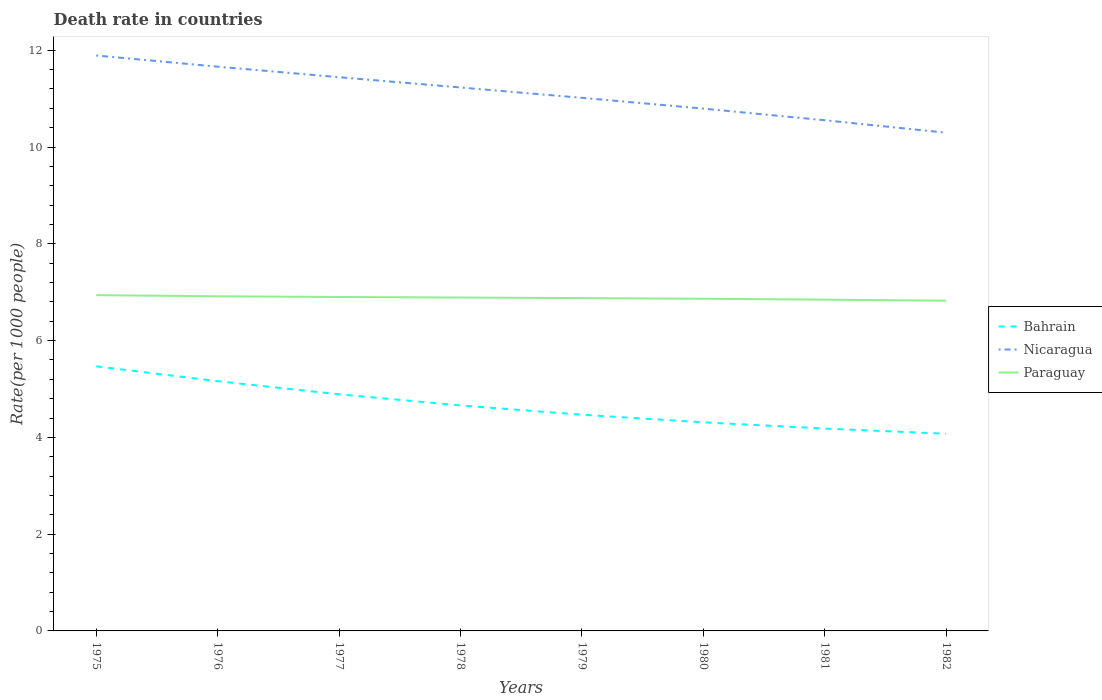Across all years, what is the maximum death rate in Bahrain?
Keep it short and to the point. 4.08. In which year was the death rate in Nicaragua maximum?
Your answer should be compact. 1982. What is the total death rate in Bahrain in the graph?
Your response must be concise. 0.58. What is the difference between the highest and the second highest death rate in Nicaragua?
Provide a short and direct response. 1.6. How many lines are there?
Your response must be concise. 3. What is the difference between two consecutive major ticks on the Y-axis?
Give a very brief answer. 2. Does the graph contain any zero values?
Your answer should be very brief. No. Does the graph contain grids?
Provide a short and direct response. No. How many legend labels are there?
Keep it short and to the point. 3. How are the legend labels stacked?
Offer a terse response. Vertical. What is the title of the graph?
Your answer should be compact. Death rate in countries. Does "Aruba" appear as one of the legend labels in the graph?
Give a very brief answer. No. What is the label or title of the Y-axis?
Provide a succinct answer. Rate(per 1000 people). What is the Rate(per 1000 people) of Bahrain in 1975?
Ensure brevity in your answer.  5.47. What is the Rate(per 1000 people) in Nicaragua in 1975?
Your response must be concise. 11.89. What is the Rate(per 1000 people) in Paraguay in 1975?
Your response must be concise. 6.94. What is the Rate(per 1000 people) of Bahrain in 1976?
Provide a succinct answer. 5.16. What is the Rate(per 1000 people) in Nicaragua in 1976?
Provide a short and direct response. 11.66. What is the Rate(per 1000 people) in Paraguay in 1976?
Keep it short and to the point. 6.92. What is the Rate(per 1000 people) in Bahrain in 1977?
Your answer should be compact. 4.89. What is the Rate(per 1000 people) of Nicaragua in 1977?
Your answer should be very brief. 11.44. What is the Rate(per 1000 people) of Paraguay in 1977?
Offer a terse response. 6.9. What is the Rate(per 1000 people) of Bahrain in 1978?
Offer a terse response. 4.66. What is the Rate(per 1000 people) in Nicaragua in 1978?
Provide a succinct answer. 11.23. What is the Rate(per 1000 people) of Paraguay in 1978?
Make the answer very short. 6.89. What is the Rate(per 1000 people) in Bahrain in 1979?
Provide a short and direct response. 4.47. What is the Rate(per 1000 people) in Nicaragua in 1979?
Give a very brief answer. 11.02. What is the Rate(per 1000 people) in Paraguay in 1979?
Your response must be concise. 6.88. What is the Rate(per 1000 people) in Bahrain in 1980?
Keep it short and to the point. 4.31. What is the Rate(per 1000 people) in Nicaragua in 1980?
Provide a short and direct response. 10.79. What is the Rate(per 1000 people) of Paraguay in 1980?
Provide a short and direct response. 6.86. What is the Rate(per 1000 people) of Bahrain in 1981?
Provide a short and direct response. 4.18. What is the Rate(per 1000 people) of Nicaragua in 1981?
Your response must be concise. 10.55. What is the Rate(per 1000 people) of Paraguay in 1981?
Your answer should be compact. 6.85. What is the Rate(per 1000 people) of Bahrain in 1982?
Offer a terse response. 4.08. What is the Rate(per 1000 people) of Nicaragua in 1982?
Offer a terse response. 10.3. What is the Rate(per 1000 people) of Paraguay in 1982?
Give a very brief answer. 6.82. Across all years, what is the maximum Rate(per 1000 people) of Bahrain?
Provide a short and direct response. 5.47. Across all years, what is the maximum Rate(per 1000 people) in Nicaragua?
Your response must be concise. 11.89. Across all years, what is the maximum Rate(per 1000 people) in Paraguay?
Offer a terse response. 6.94. Across all years, what is the minimum Rate(per 1000 people) in Bahrain?
Offer a very short reply. 4.08. Across all years, what is the minimum Rate(per 1000 people) in Nicaragua?
Ensure brevity in your answer.  10.3. Across all years, what is the minimum Rate(per 1000 people) in Paraguay?
Ensure brevity in your answer.  6.82. What is the total Rate(per 1000 people) of Bahrain in the graph?
Give a very brief answer. 37.22. What is the total Rate(per 1000 people) of Nicaragua in the graph?
Make the answer very short. 88.89. What is the total Rate(per 1000 people) of Paraguay in the graph?
Offer a terse response. 55.06. What is the difference between the Rate(per 1000 people) of Bahrain in 1975 and that in 1976?
Your answer should be compact. 0.31. What is the difference between the Rate(per 1000 people) of Nicaragua in 1975 and that in 1976?
Your answer should be compact. 0.23. What is the difference between the Rate(per 1000 people) of Paraguay in 1975 and that in 1976?
Keep it short and to the point. 0.02. What is the difference between the Rate(per 1000 people) of Bahrain in 1975 and that in 1977?
Your answer should be very brief. 0.58. What is the difference between the Rate(per 1000 people) in Nicaragua in 1975 and that in 1977?
Provide a succinct answer. 0.45. What is the difference between the Rate(per 1000 people) of Paraguay in 1975 and that in 1977?
Give a very brief answer. 0.04. What is the difference between the Rate(per 1000 people) of Bahrain in 1975 and that in 1978?
Keep it short and to the point. 0.81. What is the difference between the Rate(per 1000 people) of Nicaragua in 1975 and that in 1978?
Your response must be concise. 0.66. What is the difference between the Rate(per 1000 people) in Paraguay in 1975 and that in 1978?
Make the answer very short. 0.05. What is the difference between the Rate(per 1000 people) of Bahrain in 1975 and that in 1979?
Your answer should be compact. 1. What is the difference between the Rate(per 1000 people) of Paraguay in 1975 and that in 1979?
Your response must be concise. 0.06. What is the difference between the Rate(per 1000 people) of Bahrain in 1975 and that in 1980?
Your response must be concise. 1.16. What is the difference between the Rate(per 1000 people) in Nicaragua in 1975 and that in 1980?
Keep it short and to the point. 1.1. What is the difference between the Rate(per 1000 people) in Paraguay in 1975 and that in 1980?
Offer a very short reply. 0.07. What is the difference between the Rate(per 1000 people) in Bahrain in 1975 and that in 1981?
Give a very brief answer. 1.29. What is the difference between the Rate(per 1000 people) of Nicaragua in 1975 and that in 1981?
Provide a succinct answer. 1.34. What is the difference between the Rate(per 1000 people) of Paraguay in 1975 and that in 1981?
Your answer should be compact. 0.09. What is the difference between the Rate(per 1000 people) in Bahrain in 1975 and that in 1982?
Your answer should be very brief. 1.39. What is the difference between the Rate(per 1000 people) in Nicaragua in 1975 and that in 1982?
Ensure brevity in your answer.  1.6. What is the difference between the Rate(per 1000 people) of Paraguay in 1975 and that in 1982?
Offer a terse response. 0.12. What is the difference between the Rate(per 1000 people) of Bahrain in 1976 and that in 1977?
Ensure brevity in your answer.  0.27. What is the difference between the Rate(per 1000 people) in Nicaragua in 1976 and that in 1977?
Make the answer very short. 0.22. What is the difference between the Rate(per 1000 people) in Paraguay in 1976 and that in 1977?
Offer a terse response. 0.01. What is the difference between the Rate(per 1000 people) in Bahrain in 1976 and that in 1978?
Ensure brevity in your answer.  0.5. What is the difference between the Rate(per 1000 people) of Nicaragua in 1976 and that in 1978?
Provide a succinct answer. 0.43. What is the difference between the Rate(per 1000 people) of Paraguay in 1976 and that in 1978?
Give a very brief answer. 0.03. What is the difference between the Rate(per 1000 people) of Bahrain in 1976 and that in 1979?
Provide a short and direct response. 0.69. What is the difference between the Rate(per 1000 people) of Nicaragua in 1976 and that in 1979?
Ensure brevity in your answer.  0.64. What is the difference between the Rate(per 1000 people) of Paraguay in 1976 and that in 1979?
Keep it short and to the point. 0.04. What is the difference between the Rate(per 1000 people) in Nicaragua in 1976 and that in 1980?
Your answer should be compact. 0.87. What is the difference between the Rate(per 1000 people) in Paraguay in 1976 and that in 1980?
Keep it short and to the point. 0.05. What is the difference between the Rate(per 1000 people) in Nicaragua in 1976 and that in 1981?
Ensure brevity in your answer.  1.11. What is the difference between the Rate(per 1000 people) in Paraguay in 1976 and that in 1981?
Offer a very short reply. 0.07. What is the difference between the Rate(per 1000 people) of Bahrain in 1976 and that in 1982?
Offer a very short reply. 1.09. What is the difference between the Rate(per 1000 people) in Nicaragua in 1976 and that in 1982?
Make the answer very short. 1.36. What is the difference between the Rate(per 1000 people) in Paraguay in 1976 and that in 1982?
Keep it short and to the point. 0.09. What is the difference between the Rate(per 1000 people) of Bahrain in 1977 and that in 1978?
Make the answer very short. 0.23. What is the difference between the Rate(per 1000 people) in Nicaragua in 1977 and that in 1978?
Offer a very short reply. 0.21. What is the difference between the Rate(per 1000 people) of Paraguay in 1977 and that in 1978?
Offer a terse response. 0.01. What is the difference between the Rate(per 1000 people) of Bahrain in 1977 and that in 1979?
Your response must be concise. 0.42. What is the difference between the Rate(per 1000 people) in Nicaragua in 1977 and that in 1979?
Keep it short and to the point. 0.43. What is the difference between the Rate(per 1000 people) of Paraguay in 1977 and that in 1979?
Give a very brief answer. 0.02. What is the difference between the Rate(per 1000 people) in Bahrain in 1977 and that in 1980?
Make the answer very short. 0.58. What is the difference between the Rate(per 1000 people) of Nicaragua in 1977 and that in 1980?
Make the answer very short. 0.65. What is the difference between the Rate(per 1000 people) in Paraguay in 1977 and that in 1980?
Provide a short and direct response. 0.04. What is the difference between the Rate(per 1000 people) in Bahrain in 1977 and that in 1981?
Offer a very short reply. 0.71. What is the difference between the Rate(per 1000 people) of Nicaragua in 1977 and that in 1981?
Offer a terse response. 0.89. What is the difference between the Rate(per 1000 people) of Paraguay in 1977 and that in 1981?
Offer a very short reply. 0.06. What is the difference between the Rate(per 1000 people) of Bahrain in 1977 and that in 1982?
Your answer should be compact. 0.81. What is the difference between the Rate(per 1000 people) of Nicaragua in 1977 and that in 1982?
Your answer should be compact. 1.15. What is the difference between the Rate(per 1000 people) of Paraguay in 1977 and that in 1982?
Your response must be concise. 0.08. What is the difference between the Rate(per 1000 people) in Bahrain in 1978 and that in 1979?
Offer a very short reply. 0.19. What is the difference between the Rate(per 1000 people) in Nicaragua in 1978 and that in 1979?
Provide a short and direct response. 0.21. What is the difference between the Rate(per 1000 people) in Paraguay in 1978 and that in 1979?
Your response must be concise. 0.01. What is the difference between the Rate(per 1000 people) of Bahrain in 1978 and that in 1980?
Your answer should be compact. 0.35. What is the difference between the Rate(per 1000 people) of Nicaragua in 1978 and that in 1980?
Give a very brief answer. 0.44. What is the difference between the Rate(per 1000 people) of Paraguay in 1978 and that in 1980?
Your answer should be compact. 0.03. What is the difference between the Rate(per 1000 people) of Bahrain in 1978 and that in 1981?
Offer a very short reply. 0.48. What is the difference between the Rate(per 1000 people) in Nicaragua in 1978 and that in 1981?
Your answer should be very brief. 0.68. What is the difference between the Rate(per 1000 people) in Paraguay in 1978 and that in 1981?
Your response must be concise. 0.04. What is the difference between the Rate(per 1000 people) of Bahrain in 1978 and that in 1982?
Offer a terse response. 0.58. What is the difference between the Rate(per 1000 people) in Nicaragua in 1978 and that in 1982?
Make the answer very short. 0.94. What is the difference between the Rate(per 1000 people) in Paraguay in 1978 and that in 1982?
Your answer should be compact. 0.07. What is the difference between the Rate(per 1000 people) in Bahrain in 1979 and that in 1980?
Ensure brevity in your answer.  0.16. What is the difference between the Rate(per 1000 people) of Nicaragua in 1979 and that in 1980?
Your answer should be very brief. 0.22. What is the difference between the Rate(per 1000 people) of Paraguay in 1979 and that in 1980?
Your answer should be very brief. 0.01. What is the difference between the Rate(per 1000 people) of Bahrain in 1979 and that in 1981?
Make the answer very short. 0.29. What is the difference between the Rate(per 1000 people) of Nicaragua in 1979 and that in 1981?
Your response must be concise. 0.46. What is the difference between the Rate(per 1000 people) in Paraguay in 1979 and that in 1981?
Ensure brevity in your answer.  0.03. What is the difference between the Rate(per 1000 people) of Bahrain in 1979 and that in 1982?
Your answer should be very brief. 0.39. What is the difference between the Rate(per 1000 people) in Nicaragua in 1979 and that in 1982?
Your answer should be compact. 0.72. What is the difference between the Rate(per 1000 people) in Paraguay in 1979 and that in 1982?
Ensure brevity in your answer.  0.05. What is the difference between the Rate(per 1000 people) of Bahrain in 1980 and that in 1981?
Offer a terse response. 0.13. What is the difference between the Rate(per 1000 people) in Nicaragua in 1980 and that in 1981?
Offer a terse response. 0.24. What is the difference between the Rate(per 1000 people) of Paraguay in 1980 and that in 1981?
Provide a short and direct response. 0.02. What is the difference between the Rate(per 1000 people) of Bahrain in 1980 and that in 1982?
Keep it short and to the point. 0.24. What is the difference between the Rate(per 1000 people) in Nicaragua in 1980 and that in 1982?
Make the answer very short. 0.5. What is the difference between the Rate(per 1000 people) in Paraguay in 1980 and that in 1982?
Your answer should be very brief. 0.04. What is the difference between the Rate(per 1000 people) in Bahrain in 1981 and that in 1982?
Your response must be concise. 0.11. What is the difference between the Rate(per 1000 people) in Nicaragua in 1981 and that in 1982?
Offer a very short reply. 0.26. What is the difference between the Rate(per 1000 people) in Paraguay in 1981 and that in 1982?
Your answer should be very brief. 0.02. What is the difference between the Rate(per 1000 people) in Bahrain in 1975 and the Rate(per 1000 people) in Nicaragua in 1976?
Your answer should be very brief. -6.19. What is the difference between the Rate(per 1000 people) in Bahrain in 1975 and the Rate(per 1000 people) in Paraguay in 1976?
Offer a terse response. -1.45. What is the difference between the Rate(per 1000 people) in Nicaragua in 1975 and the Rate(per 1000 people) in Paraguay in 1976?
Ensure brevity in your answer.  4.98. What is the difference between the Rate(per 1000 people) in Bahrain in 1975 and the Rate(per 1000 people) in Nicaragua in 1977?
Offer a very short reply. -5.97. What is the difference between the Rate(per 1000 people) in Bahrain in 1975 and the Rate(per 1000 people) in Paraguay in 1977?
Your answer should be compact. -1.43. What is the difference between the Rate(per 1000 people) of Nicaragua in 1975 and the Rate(per 1000 people) of Paraguay in 1977?
Your response must be concise. 4.99. What is the difference between the Rate(per 1000 people) in Bahrain in 1975 and the Rate(per 1000 people) in Nicaragua in 1978?
Keep it short and to the point. -5.76. What is the difference between the Rate(per 1000 people) of Bahrain in 1975 and the Rate(per 1000 people) of Paraguay in 1978?
Give a very brief answer. -1.42. What is the difference between the Rate(per 1000 people) of Nicaragua in 1975 and the Rate(per 1000 people) of Paraguay in 1978?
Offer a very short reply. 5. What is the difference between the Rate(per 1000 people) in Bahrain in 1975 and the Rate(per 1000 people) in Nicaragua in 1979?
Keep it short and to the point. -5.55. What is the difference between the Rate(per 1000 people) of Bahrain in 1975 and the Rate(per 1000 people) of Paraguay in 1979?
Your answer should be compact. -1.41. What is the difference between the Rate(per 1000 people) of Nicaragua in 1975 and the Rate(per 1000 people) of Paraguay in 1979?
Provide a short and direct response. 5.01. What is the difference between the Rate(per 1000 people) of Bahrain in 1975 and the Rate(per 1000 people) of Nicaragua in 1980?
Make the answer very short. -5.33. What is the difference between the Rate(per 1000 people) in Bahrain in 1975 and the Rate(per 1000 people) in Paraguay in 1980?
Offer a very short reply. -1.4. What is the difference between the Rate(per 1000 people) of Nicaragua in 1975 and the Rate(per 1000 people) of Paraguay in 1980?
Keep it short and to the point. 5.03. What is the difference between the Rate(per 1000 people) in Bahrain in 1975 and the Rate(per 1000 people) in Nicaragua in 1981?
Ensure brevity in your answer.  -5.09. What is the difference between the Rate(per 1000 people) in Bahrain in 1975 and the Rate(per 1000 people) in Paraguay in 1981?
Ensure brevity in your answer.  -1.38. What is the difference between the Rate(per 1000 people) in Nicaragua in 1975 and the Rate(per 1000 people) in Paraguay in 1981?
Your answer should be compact. 5.05. What is the difference between the Rate(per 1000 people) in Bahrain in 1975 and the Rate(per 1000 people) in Nicaragua in 1982?
Make the answer very short. -4.83. What is the difference between the Rate(per 1000 people) in Bahrain in 1975 and the Rate(per 1000 people) in Paraguay in 1982?
Your answer should be compact. -1.36. What is the difference between the Rate(per 1000 people) in Nicaragua in 1975 and the Rate(per 1000 people) in Paraguay in 1982?
Provide a short and direct response. 5.07. What is the difference between the Rate(per 1000 people) of Bahrain in 1976 and the Rate(per 1000 people) of Nicaragua in 1977?
Keep it short and to the point. -6.28. What is the difference between the Rate(per 1000 people) in Bahrain in 1976 and the Rate(per 1000 people) in Paraguay in 1977?
Keep it short and to the point. -1.74. What is the difference between the Rate(per 1000 people) of Nicaragua in 1976 and the Rate(per 1000 people) of Paraguay in 1977?
Offer a terse response. 4.76. What is the difference between the Rate(per 1000 people) of Bahrain in 1976 and the Rate(per 1000 people) of Nicaragua in 1978?
Offer a very short reply. -6.07. What is the difference between the Rate(per 1000 people) of Bahrain in 1976 and the Rate(per 1000 people) of Paraguay in 1978?
Offer a terse response. -1.73. What is the difference between the Rate(per 1000 people) in Nicaragua in 1976 and the Rate(per 1000 people) in Paraguay in 1978?
Your answer should be compact. 4.77. What is the difference between the Rate(per 1000 people) of Bahrain in 1976 and the Rate(per 1000 people) of Nicaragua in 1979?
Offer a terse response. -5.86. What is the difference between the Rate(per 1000 people) of Bahrain in 1976 and the Rate(per 1000 people) of Paraguay in 1979?
Provide a succinct answer. -1.72. What is the difference between the Rate(per 1000 people) in Nicaragua in 1976 and the Rate(per 1000 people) in Paraguay in 1979?
Offer a very short reply. 4.78. What is the difference between the Rate(per 1000 people) in Bahrain in 1976 and the Rate(per 1000 people) in Nicaragua in 1980?
Give a very brief answer. -5.63. What is the difference between the Rate(per 1000 people) in Bahrain in 1976 and the Rate(per 1000 people) in Paraguay in 1980?
Your answer should be compact. -1.7. What is the difference between the Rate(per 1000 people) of Nicaragua in 1976 and the Rate(per 1000 people) of Paraguay in 1980?
Your answer should be very brief. 4.8. What is the difference between the Rate(per 1000 people) of Bahrain in 1976 and the Rate(per 1000 people) of Nicaragua in 1981?
Keep it short and to the point. -5.39. What is the difference between the Rate(per 1000 people) of Bahrain in 1976 and the Rate(per 1000 people) of Paraguay in 1981?
Offer a very short reply. -1.69. What is the difference between the Rate(per 1000 people) of Nicaragua in 1976 and the Rate(per 1000 people) of Paraguay in 1981?
Your response must be concise. 4.82. What is the difference between the Rate(per 1000 people) of Bahrain in 1976 and the Rate(per 1000 people) of Nicaragua in 1982?
Ensure brevity in your answer.  -5.13. What is the difference between the Rate(per 1000 people) in Bahrain in 1976 and the Rate(per 1000 people) in Paraguay in 1982?
Your response must be concise. -1.66. What is the difference between the Rate(per 1000 people) of Nicaragua in 1976 and the Rate(per 1000 people) of Paraguay in 1982?
Make the answer very short. 4.84. What is the difference between the Rate(per 1000 people) in Bahrain in 1977 and the Rate(per 1000 people) in Nicaragua in 1978?
Give a very brief answer. -6.34. What is the difference between the Rate(per 1000 people) in Nicaragua in 1977 and the Rate(per 1000 people) in Paraguay in 1978?
Provide a succinct answer. 4.55. What is the difference between the Rate(per 1000 people) of Bahrain in 1977 and the Rate(per 1000 people) of Nicaragua in 1979?
Keep it short and to the point. -6.13. What is the difference between the Rate(per 1000 people) of Bahrain in 1977 and the Rate(per 1000 people) of Paraguay in 1979?
Provide a short and direct response. -1.99. What is the difference between the Rate(per 1000 people) in Nicaragua in 1977 and the Rate(per 1000 people) in Paraguay in 1979?
Offer a terse response. 4.57. What is the difference between the Rate(per 1000 people) of Bahrain in 1977 and the Rate(per 1000 people) of Nicaragua in 1980?
Your answer should be compact. -5.9. What is the difference between the Rate(per 1000 people) in Bahrain in 1977 and the Rate(per 1000 people) in Paraguay in 1980?
Your answer should be compact. -1.97. What is the difference between the Rate(per 1000 people) in Nicaragua in 1977 and the Rate(per 1000 people) in Paraguay in 1980?
Your answer should be very brief. 4.58. What is the difference between the Rate(per 1000 people) in Bahrain in 1977 and the Rate(per 1000 people) in Nicaragua in 1981?
Offer a terse response. -5.66. What is the difference between the Rate(per 1000 people) in Bahrain in 1977 and the Rate(per 1000 people) in Paraguay in 1981?
Give a very brief answer. -1.96. What is the difference between the Rate(per 1000 people) in Nicaragua in 1977 and the Rate(per 1000 people) in Paraguay in 1981?
Provide a short and direct response. 4.6. What is the difference between the Rate(per 1000 people) in Bahrain in 1977 and the Rate(per 1000 people) in Nicaragua in 1982?
Your response must be concise. -5.41. What is the difference between the Rate(per 1000 people) of Bahrain in 1977 and the Rate(per 1000 people) of Paraguay in 1982?
Offer a terse response. -1.93. What is the difference between the Rate(per 1000 people) of Nicaragua in 1977 and the Rate(per 1000 people) of Paraguay in 1982?
Keep it short and to the point. 4.62. What is the difference between the Rate(per 1000 people) of Bahrain in 1978 and the Rate(per 1000 people) of Nicaragua in 1979?
Provide a short and direct response. -6.36. What is the difference between the Rate(per 1000 people) of Bahrain in 1978 and the Rate(per 1000 people) of Paraguay in 1979?
Keep it short and to the point. -2.22. What is the difference between the Rate(per 1000 people) of Nicaragua in 1978 and the Rate(per 1000 people) of Paraguay in 1979?
Keep it short and to the point. 4.35. What is the difference between the Rate(per 1000 people) in Bahrain in 1978 and the Rate(per 1000 people) in Nicaragua in 1980?
Ensure brevity in your answer.  -6.13. What is the difference between the Rate(per 1000 people) in Bahrain in 1978 and the Rate(per 1000 people) in Paraguay in 1980?
Provide a succinct answer. -2.2. What is the difference between the Rate(per 1000 people) of Nicaragua in 1978 and the Rate(per 1000 people) of Paraguay in 1980?
Make the answer very short. 4.37. What is the difference between the Rate(per 1000 people) in Bahrain in 1978 and the Rate(per 1000 people) in Nicaragua in 1981?
Provide a short and direct response. -5.89. What is the difference between the Rate(per 1000 people) in Bahrain in 1978 and the Rate(per 1000 people) in Paraguay in 1981?
Ensure brevity in your answer.  -2.19. What is the difference between the Rate(per 1000 people) in Nicaragua in 1978 and the Rate(per 1000 people) in Paraguay in 1981?
Your answer should be very brief. 4.38. What is the difference between the Rate(per 1000 people) in Bahrain in 1978 and the Rate(per 1000 people) in Nicaragua in 1982?
Ensure brevity in your answer.  -5.64. What is the difference between the Rate(per 1000 people) in Bahrain in 1978 and the Rate(per 1000 people) in Paraguay in 1982?
Offer a terse response. -2.16. What is the difference between the Rate(per 1000 people) in Nicaragua in 1978 and the Rate(per 1000 people) in Paraguay in 1982?
Ensure brevity in your answer.  4.41. What is the difference between the Rate(per 1000 people) in Bahrain in 1979 and the Rate(per 1000 people) in Nicaragua in 1980?
Your answer should be very brief. -6.33. What is the difference between the Rate(per 1000 people) in Bahrain in 1979 and the Rate(per 1000 people) in Paraguay in 1980?
Your answer should be very brief. -2.4. What is the difference between the Rate(per 1000 people) of Nicaragua in 1979 and the Rate(per 1000 people) of Paraguay in 1980?
Provide a short and direct response. 4.15. What is the difference between the Rate(per 1000 people) in Bahrain in 1979 and the Rate(per 1000 people) in Nicaragua in 1981?
Your answer should be very brief. -6.09. What is the difference between the Rate(per 1000 people) of Bahrain in 1979 and the Rate(per 1000 people) of Paraguay in 1981?
Make the answer very short. -2.38. What is the difference between the Rate(per 1000 people) of Nicaragua in 1979 and the Rate(per 1000 people) of Paraguay in 1981?
Provide a succinct answer. 4.17. What is the difference between the Rate(per 1000 people) in Bahrain in 1979 and the Rate(per 1000 people) in Nicaragua in 1982?
Offer a very short reply. -5.83. What is the difference between the Rate(per 1000 people) in Bahrain in 1979 and the Rate(per 1000 people) in Paraguay in 1982?
Your answer should be very brief. -2.36. What is the difference between the Rate(per 1000 people) of Nicaragua in 1979 and the Rate(per 1000 people) of Paraguay in 1982?
Provide a succinct answer. 4.19. What is the difference between the Rate(per 1000 people) of Bahrain in 1980 and the Rate(per 1000 people) of Nicaragua in 1981?
Your response must be concise. -6.24. What is the difference between the Rate(per 1000 people) in Bahrain in 1980 and the Rate(per 1000 people) in Paraguay in 1981?
Your answer should be compact. -2.54. What is the difference between the Rate(per 1000 people) in Nicaragua in 1980 and the Rate(per 1000 people) in Paraguay in 1981?
Make the answer very short. 3.95. What is the difference between the Rate(per 1000 people) in Bahrain in 1980 and the Rate(per 1000 people) in Nicaragua in 1982?
Provide a short and direct response. -5.99. What is the difference between the Rate(per 1000 people) of Bahrain in 1980 and the Rate(per 1000 people) of Paraguay in 1982?
Ensure brevity in your answer.  -2.51. What is the difference between the Rate(per 1000 people) of Nicaragua in 1980 and the Rate(per 1000 people) of Paraguay in 1982?
Provide a succinct answer. 3.97. What is the difference between the Rate(per 1000 people) in Bahrain in 1981 and the Rate(per 1000 people) in Nicaragua in 1982?
Provide a short and direct response. -6.11. What is the difference between the Rate(per 1000 people) in Bahrain in 1981 and the Rate(per 1000 people) in Paraguay in 1982?
Offer a very short reply. -2.64. What is the difference between the Rate(per 1000 people) in Nicaragua in 1981 and the Rate(per 1000 people) in Paraguay in 1982?
Ensure brevity in your answer.  3.73. What is the average Rate(per 1000 people) in Bahrain per year?
Your answer should be compact. 4.65. What is the average Rate(per 1000 people) of Nicaragua per year?
Offer a very short reply. 11.11. What is the average Rate(per 1000 people) in Paraguay per year?
Offer a very short reply. 6.88. In the year 1975, what is the difference between the Rate(per 1000 people) in Bahrain and Rate(per 1000 people) in Nicaragua?
Offer a terse response. -6.42. In the year 1975, what is the difference between the Rate(per 1000 people) in Bahrain and Rate(per 1000 people) in Paraguay?
Offer a very short reply. -1.47. In the year 1975, what is the difference between the Rate(per 1000 people) in Nicaragua and Rate(per 1000 people) in Paraguay?
Offer a very short reply. 4.95. In the year 1976, what is the difference between the Rate(per 1000 people) in Bahrain and Rate(per 1000 people) in Paraguay?
Offer a terse response. -1.75. In the year 1976, what is the difference between the Rate(per 1000 people) of Nicaragua and Rate(per 1000 people) of Paraguay?
Make the answer very short. 4.75. In the year 1977, what is the difference between the Rate(per 1000 people) in Bahrain and Rate(per 1000 people) in Nicaragua?
Offer a very short reply. -6.55. In the year 1977, what is the difference between the Rate(per 1000 people) in Bahrain and Rate(per 1000 people) in Paraguay?
Your answer should be compact. -2.01. In the year 1977, what is the difference between the Rate(per 1000 people) in Nicaragua and Rate(per 1000 people) in Paraguay?
Offer a terse response. 4.54. In the year 1978, what is the difference between the Rate(per 1000 people) of Bahrain and Rate(per 1000 people) of Nicaragua?
Offer a terse response. -6.57. In the year 1978, what is the difference between the Rate(per 1000 people) of Bahrain and Rate(per 1000 people) of Paraguay?
Your response must be concise. -2.23. In the year 1978, what is the difference between the Rate(per 1000 people) of Nicaragua and Rate(per 1000 people) of Paraguay?
Offer a terse response. 4.34. In the year 1979, what is the difference between the Rate(per 1000 people) in Bahrain and Rate(per 1000 people) in Nicaragua?
Give a very brief answer. -6.55. In the year 1979, what is the difference between the Rate(per 1000 people) of Bahrain and Rate(per 1000 people) of Paraguay?
Make the answer very short. -2.41. In the year 1979, what is the difference between the Rate(per 1000 people) of Nicaragua and Rate(per 1000 people) of Paraguay?
Your answer should be compact. 4.14. In the year 1980, what is the difference between the Rate(per 1000 people) of Bahrain and Rate(per 1000 people) of Nicaragua?
Give a very brief answer. -6.48. In the year 1980, what is the difference between the Rate(per 1000 people) in Bahrain and Rate(per 1000 people) in Paraguay?
Make the answer very short. -2.55. In the year 1980, what is the difference between the Rate(per 1000 people) of Nicaragua and Rate(per 1000 people) of Paraguay?
Give a very brief answer. 3.93. In the year 1981, what is the difference between the Rate(per 1000 people) in Bahrain and Rate(per 1000 people) in Nicaragua?
Give a very brief answer. -6.37. In the year 1981, what is the difference between the Rate(per 1000 people) in Bahrain and Rate(per 1000 people) in Paraguay?
Provide a short and direct response. -2.66. In the year 1981, what is the difference between the Rate(per 1000 people) of Nicaragua and Rate(per 1000 people) of Paraguay?
Offer a terse response. 3.71. In the year 1982, what is the difference between the Rate(per 1000 people) in Bahrain and Rate(per 1000 people) in Nicaragua?
Offer a terse response. -6.22. In the year 1982, what is the difference between the Rate(per 1000 people) in Bahrain and Rate(per 1000 people) in Paraguay?
Offer a terse response. -2.75. In the year 1982, what is the difference between the Rate(per 1000 people) in Nicaragua and Rate(per 1000 people) in Paraguay?
Provide a succinct answer. 3.47. What is the ratio of the Rate(per 1000 people) of Bahrain in 1975 to that in 1976?
Offer a very short reply. 1.06. What is the ratio of the Rate(per 1000 people) of Nicaragua in 1975 to that in 1976?
Keep it short and to the point. 1.02. What is the ratio of the Rate(per 1000 people) in Bahrain in 1975 to that in 1977?
Your answer should be compact. 1.12. What is the ratio of the Rate(per 1000 people) of Nicaragua in 1975 to that in 1977?
Your answer should be very brief. 1.04. What is the ratio of the Rate(per 1000 people) of Bahrain in 1975 to that in 1978?
Provide a succinct answer. 1.17. What is the ratio of the Rate(per 1000 people) of Nicaragua in 1975 to that in 1978?
Ensure brevity in your answer.  1.06. What is the ratio of the Rate(per 1000 people) of Paraguay in 1975 to that in 1978?
Provide a succinct answer. 1.01. What is the ratio of the Rate(per 1000 people) in Bahrain in 1975 to that in 1979?
Keep it short and to the point. 1.22. What is the ratio of the Rate(per 1000 people) in Nicaragua in 1975 to that in 1979?
Provide a short and direct response. 1.08. What is the ratio of the Rate(per 1000 people) of Paraguay in 1975 to that in 1979?
Your response must be concise. 1.01. What is the ratio of the Rate(per 1000 people) in Bahrain in 1975 to that in 1980?
Offer a terse response. 1.27. What is the ratio of the Rate(per 1000 people) of Nicaragua in 1975 to that in 1980?
Provide a succinct answer. 1.1. What is the ratio of the Rate(per 1000 people) of Paraguay in 1975 to that in 1980?
Provide a short and direct response. 1.01. What is the ratio of the Rate(per 1000 people) in Bahrain in 1975 to that in 1981?
Provide a succinct answer. 1.31. What is the ratio of the Rate(per 1000 people) of Nicaragua in 1975 to that in 1981?
Offer a terse response. 1.13. What is the ratio of the Rate(per 1000 people) in Paraguay in 1975 to that in 1981?
Your answer should be compact. 1.01. What is the ratio of the Rate(per 1000 people) in Bahrain in 1975 to that in 1982?
Keep it short and to the point. 1.34. What is the ratio of the Rate(per 1000 people) in Nicaragua in 1975 to that in 1982?
Provide a short and direct response. 1.16. What is the ratio of the Rate(per 1000 people) of Paraguay in 1975 to that in 1982?
Keep it short and to the point. 1.02. What is the ratio of the Rate(per 1000 people) in Bahrain in 1976 to that in 1977?
Your response must be concise. 1.06. What is the ratio of the Rate(per 1000 people) of Nicaragua in 1976 to that in 1977?
Make the answer very short. 1.02. What is the ratio of the Rate(per 1000 people) in Paraguay in 1976 to that in 1977?
Provide a succinct answer. 1. What is the ratio of the Rate(per 1000 people) in Bahrain in 1976 to that in 1978?
Offer a very short reply. 1.11. What is the ratio of the Rate(per 1000 people) of Nicaragua in 1976 to that in 1978?
Offer a terse response. 1.04. What is the ratio of the Rate(per 1000 people) in Bahrain in 1976 to that in 1979?
Your answer should be compact. 1.16. What is the ratio of the Rate(per 1000 people) in Nicaragua in 1976 to that in 1979?
Ensure brevity in your answer.  1.06. What is the ratio of the Rate(per 1000 people) of Paraguay in 1976 to that in 1979?
Provide a succinct answer. 1.01. What is the ratio of the Rate(per 1000 people) of Bahrain in 1976 to that in 1980?
Ensure brevity in your answer.  1.2. What is the ratio of the Rate(per 1000 people) in Nicaragua in 1976 to that in 1980?
Your answer should be very brief. 1.08. What is the ratio of the Rate(per 1000 people) in Paraguay in 1976 to that in 1980?
Your answer should be very brief. 1.01. What is the ratio of the Rate(per 1000 people) of Bahrain in 1976 to that in 1981?
Offer a very short reply. 1.23. What is the ratio of the Rate(per 1000 people) of Nicaragua in 1976 to that in 1981?
Your answer should be compact. 1.1. What is the ratio of the Rate(per 1000 people) of Paraguay in 1976 to that in 1981?
Ensure brevity in your answer.  1.01. What is the ratio of the Rate(per 1000 people) in Bahrain in 1976 to that in 1982?
Your response must be concise. 1.27. What is the ratio of the Rate(per 1000 people) in Nicaragua in 1976 to that in 1982?
Ensure brevity in your answer.  1.13. What is the ratio of the Rate(per 1000 people) of Paraguay in 1976 to that in 1982?
Provide a succinct answer. 1.01. What is the ratio of the Rate(per 1000 people) in Bahrain in 1977 to that in 1978?
Make the answer very short. 1.05. What is the ratio of the Rate(per 1000 people) of Nicaragua in 1977 to that in 1978?
Provide a succinct answer. 1.02. What is the ratio of the Rate(per 1000 people) of Paraguay in 1977 to that in 1978?
Your response must be concise. 1. What is the ratio of the Rate(per 1000 people) in Bahrain in 1977 to that in 1979?
Give a very brief answer. 1.09. What is the ratio of the Rate(per 1000 people) of Nicaragua in 1977 to that in 1979?
Provide a short and direct response. 1.04. What is the ratio of the Rate(per 1000 people) of Bahrain in 1977 to that in 1980?
Your answer should be compact. 1.13. What is the ratio of the Rate(per 1000 people) of Nicaragua in 1977 to that in 1980?
Your answer should be compact. 1.06. What is the ratio of the Rate(per 1000 people) in Paraguay in 1977 to that in 1980?
Offer a terse response. 1.01. What is the ratio of the Rate(per 1000 people) in Bahrain in 1977 to that in 1981?
Provide a short and direct response. 1.17. What is the ratio of the Rate(per 1000 people) of Nicaragua in 1977 to that in 1981?
Provide a short and direct response. 1.08. What is the ratio of the Rate(per 1000 people) of Nicaragua in 1977 to that in 1982?
Make the answer very short. 1.11. What is the ratio of the Rate(per 1000 people) in Paraguay in 1977 to that in 1982?
Provide a succinct answer. 1.01. What is the ratio of the Rate(per 1000 people) of Bahrain in 1978 to that in 1979?
Your response must be concise. 1.04. What is the ratio of the Rate(per 1000 people) of Nicaragua in 1978 to that in 1979?
Give a very brief answer. 1.02. What is the ratio of the Rate(per 1000 people) of Paraguay in 1978 to that in 1979?
Offer a very short reply. 1. What is the ratio of the Rate(per 1000 people) in Bahrain in 1978 to that in 1980?
Ensure brevity in your answer.  1.08. What is the ratio of the Rate(per 1000 people) in Nicaragua in 1978 to that in 1980?
Your answer should be compact. 1.04. What is the ratio of the Rate(per 1000 people) of Paraguay in 1978 to that in 1980?
Offer a terse response. 1. What is the ratio of the Rate(per 1000 people) in Bahrain in 1978 to that in 1981?
Keep it short and to the point. 1.11. What is the ratio of the Rate(per 1000 people) of Nicaragua in 1978 to that in 1981?
Ensure brevity in your answer.  1.06. What is the ratio of the Rate(per 1000 people) of Paraguay in 1978 to that in 1981?
Make the answer very short. 1.01. What is the ratio of the Rate(per 1000 people) in Bahrain in 1978 to that in 1982?
Provide a short and direct response. 1.14. What is the ratio of the Rate(per 1000 people) in Nicaragua in 1978 to that in 1982?
Ensure brevity in your answer.  1.09. What is the ratio of the Rate(per 1000 people) of Paraguay in 1978 to that in 1982?
Give a very brief answer. 1.01. What is the ratio of the Rate(per 1000 people) in Bahrain in 1979 to that in 1980?
Your answer should be compact. 1.04. What is the ratio of the Rate(per 1000 people) of Nicaragua in 1979 to that in 1980?
Your answer should be compact. 1.02. What is the ratio of the Rate(per 1000 people) in Paraguay in 1979 to that in 1980?
Your answer should be very brief. 1. What is the ratio of the Rate(per 1000 people) in Bahrain in 1979 to that in 1981?
Keep it short and to the point. 1.07. What is the ratio of the Rate(per 1000 people) in Nicaragua in 1979 to that in 1981?
Give a very brief answer. 1.04. What is the ratio of the Rate(per 1000 people) in Bahrain in 1979 to that in 1982?
Offer a terse response. 1.1. What is the ratio of the Rate(per 1000 people) of Nicaragua in 1979 to that in 1982?
Provide a short and direct response. 1.07. What is the ratio of the Rate(per 1000 people) of Paraguay in 1979 to that in 1982?
Your response must be concise. 1.01. What is the ratio of the Rate(per 1000 people) in Bahrain in 1980 to that in 1981?
Provide a succinct answer. 1.03. What is the ratio of the Rate(per 1000 people) in Nicaragua in 1980 to that in 1981?
Your answer should be very brief. 1.02. What is the ratio of the Rate(per 1000 people) in Bahrain in 1980 to that in 1982?
Keep it short and to the point. 1.06. What is the ratio of the Rate(per 1000 people) in Nicaragua in 1980 to that in 1982?
Offer a terse response. 1.05. What is the ratio of the Rate(per 1000 people) of Paraguay in 1980 to that in 1982?
Keep it short and to the point. 1.01. What is the ratio of the Rate(per 1000 people) in Bahrain in 1981 to that in 1982?
Your answer should be very brief. 1.03. What is the ratio of the Rate(per 1000 people) in Nicaragua in 1981 to that in 1982?
Your answer should be compact. 1.03. What is the difference between the highest and the second highest Rate(per 1000 people) in Bahrain?
Ensure brevity in your answer.  0.31. What is the difference between the highest and the second highest Rate(per 1000 people) of Nicaragua?
Your answer should be very brief. 0.23. What is the difference between the highest and the second highest Rate(per 1000 people) in Paraguay?
Offer a terse response. 0.02. What is the difference between the highest and the lowest Rate(per 1000 people) in Bahrain?
Give a very brief answer. 1.39. What is the difference between the highest and the lowest Rate(per 1000 people) of Nicaragua?
Ensure brevity in your answer.  1.6. What is the difference between the highest and the lowest Rate(per 1000 people) of Paraguay?
Keep it short and to the point. 0.12. 